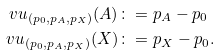<formula> <loc_0><loc_0><loc_500><loc_500>\ v u _ { ( p _ { 0 } , p _ { A } , p _ { X } ) } ( A ) & \colon = p _ { A } - p _ { 0 } \\ \ v u _ { ( p _ { 0 } , p _ { A } , p _ { X } ) } ( X ) & \colon = p _ { X } - p _ { 0 } .</formula> 